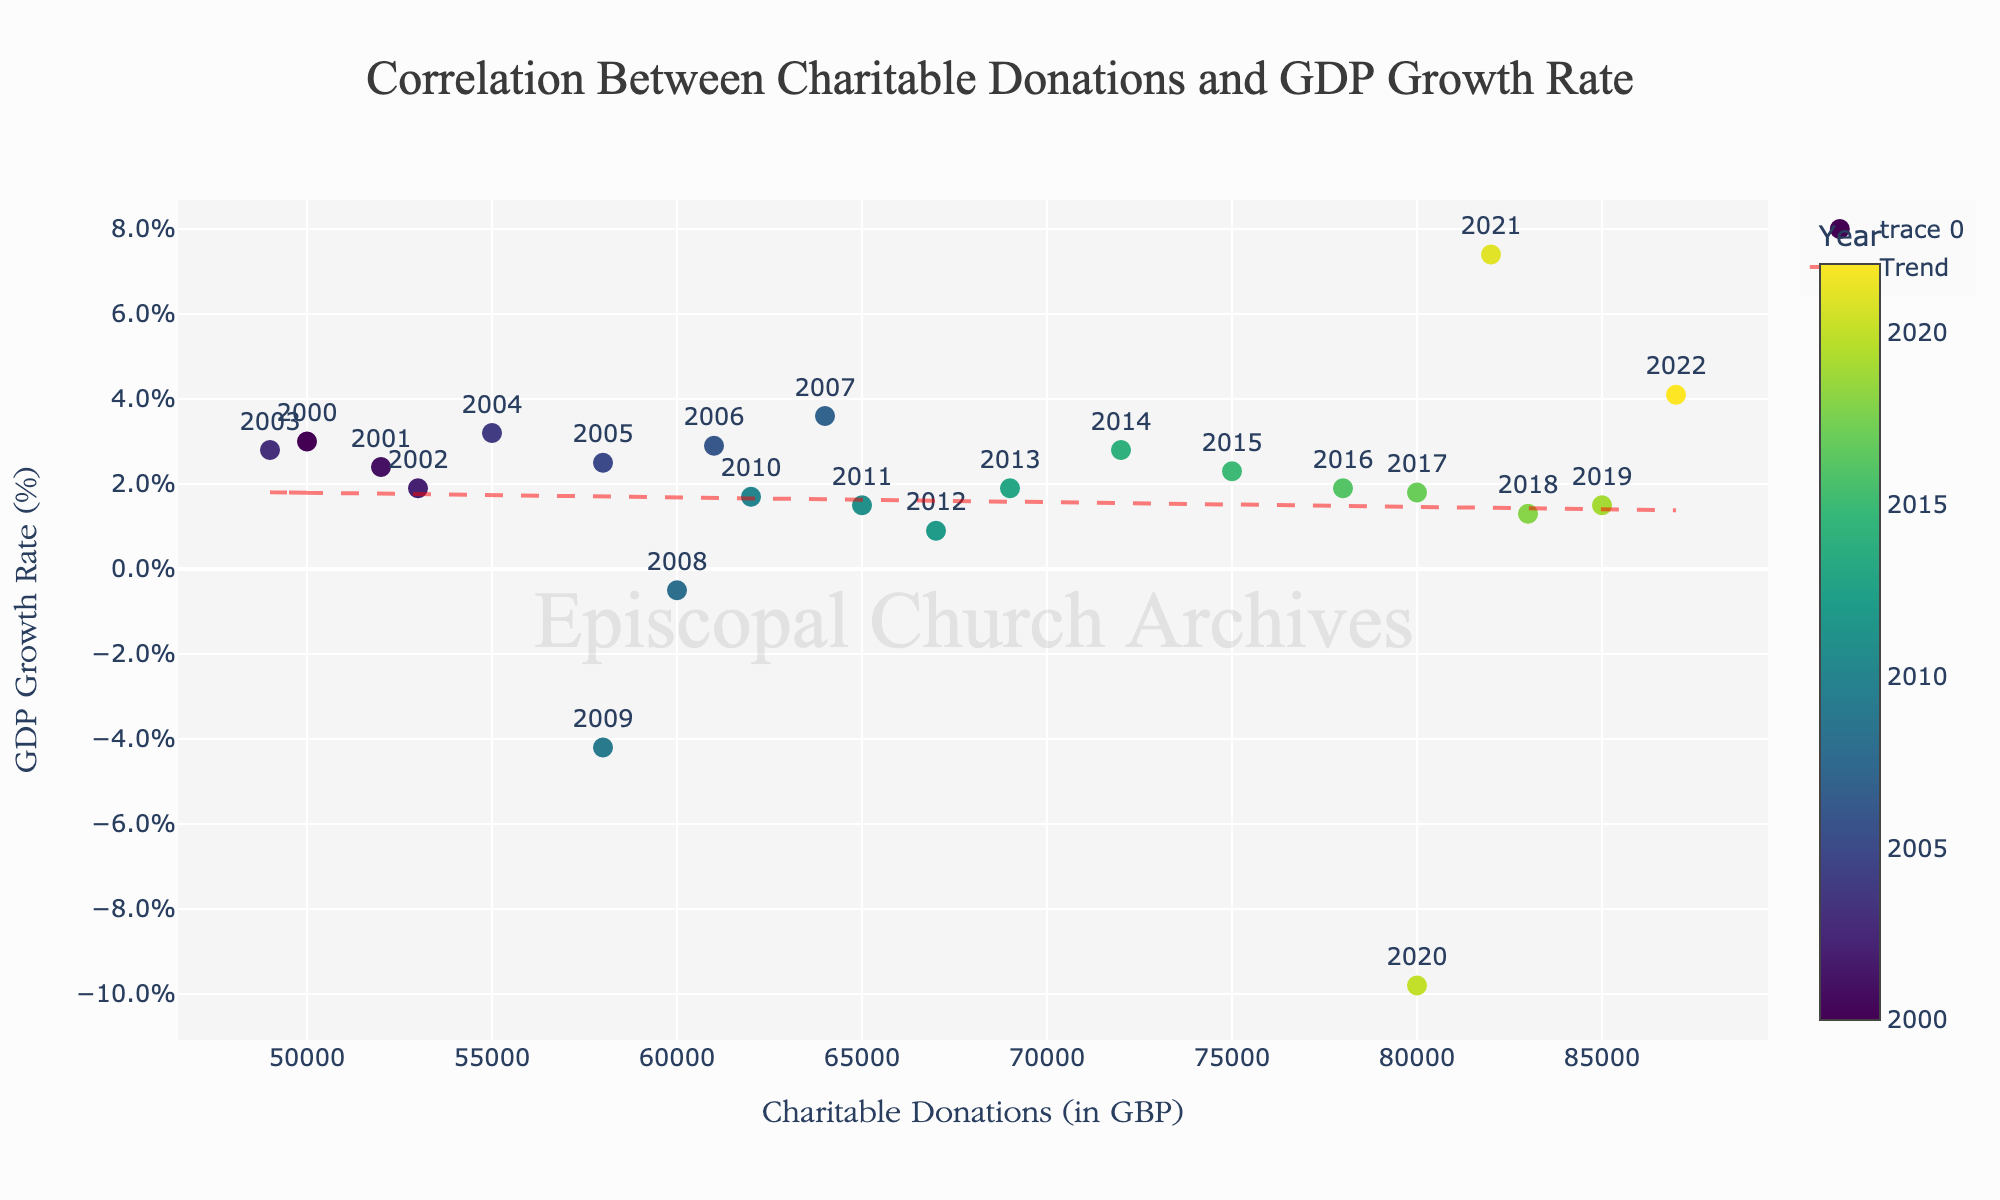What is the title of the figure? The title is positioned at the top center of the figure, and it reads "Correlation Between Charitable Donations and GDP Growth Rate"
Answer: Correlation Between Charitable Donations and GDP Growth Rate What are the labels on the x-axis and y-axis? The x-axis label is "Charitable Donations (in GBP)" and the y-axis label is "GDP Growth Rate (%)". These labels provide context for the plotted data.
Answer: Charitable Donations (in GBP) and GDP Growth Rate (%) How does the GDP growth rate change as charitable donations increase? To observe this, look at the scatter points and the trend line. Generally, the trend line shows a slight positive slope, indicating that as charitable donations increase, GDP growth tends to increase.
Answer: Increases Which year had the lowest GDP growth rate, and what were the charitable donations for that year? By examining the color scale and the data points with the hover information, we see that 2020 had the lowest GDP growth rate of -9.8%, with charitable donations at £80,000.
Answer: 2020, £80,000 Compare the GDP growth rates of the years 2009 and 2021. Which year had a higher GDP growth rate and by how much? The hover information shows that the GDP growth rate for 2009 was -4.2%, and for 2021 it was 7.4%. To find the difference, calculate 7.4% - (-4.2%) = 11.6%.
Answer: 2021, by 11.6% What does the red dashed line in the plot represent? The red dashed line is the trend line, calculated using a linear regression. It represents the overall trend between charitable donations and GDP growth rate, showing how GDP growth changes with donations over time.
Answer: Trend line Which year had the highest charitable donations, and what was the corresponding GDP growth rate for that year? The color scale indicates 2022 had the highest charitable donations at £87,000. The GDP growth rate for 2022, as shown by hovering over the point, was 4.1%.
Answer: 2022, 4.1% Calculate the average GDP growth rate for years where charitable donations were greater than £75,000. Filtering the years with donations > £75,000 (2016-2022), the GDP growth rates are 1.9%, 1.8%, 1.3%, 1.5%, -9.8%, 7.4%, 4.1%. Sum these rates and divide by the number of years: (1.9 + 1.8 + 1.3 + 1.5 - 9.8 + 7.4 + 4.1)/7 ≈ 1.17%.
Answer: 1.17% What patterns can be observed between the charitable donations and the economic indicators (GDP growth rate)? By examining the trend line and data points, there is a general positive trend, implying that higher charitable donations may correlate with higher GDP growth rates, although this is not a strict rule as some deviations are present.
Answer: Positive correlation Which year had a GDP growth rate closest to 2%, and what were the charitable donations for that year? Hovering over the data points reveals that 2002 had a GDP growth rate of 1.9%, closest to 2%, with charitable donations at £53,000.
Answer: 2002, £53,000 